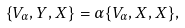Convert formula to latex. <formula><loc_0><loc_0><loc_500><loc_500>\{ V _ { \alpha } , Y , X \} = \alpha \{ V _ { \alpha } , X , X \} ,</formula> 